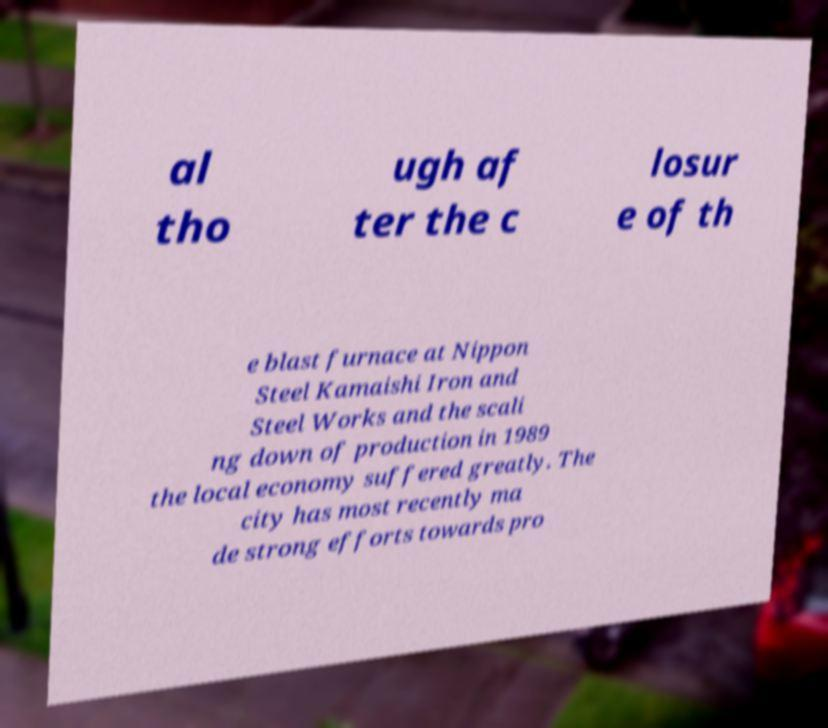For documentation purposes, I need the text within this image transcribed. Could you provide that? al tho ugh af ter the c losur e of th e blast furnace at Nippon Steel Kamaishi Iron and Steel Works and the scali ng down of production in 1989 the local economy suffered greatly. The city has most recently ma de strong efforts towards pro 